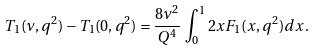<formula> <loc_0><loc_0><loc_500><loc_500>T _ { 1 } ( \nu , q ^ { 2 } ) - T _ { 1 } ( 0 , q ^ { 2 } ) = \frac { 8 \nu ^ { 2 } } { Q ^ { 4 } } \, \int _ { 0 } ^ { 1 } 2 x F _ { 1 } ( x , q ^ { 2 } ) d x \, .</formula> 